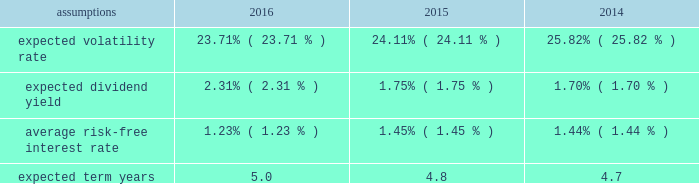Notes to the audited consolidated financial statements director stock compensation subplan eastman's 2016 director stock compensation subplan ( "directors' subplan" ) , a component of the 2012 omnibus plan , remains in effect until terminated by the board of directors or the earlier termination of thf e 2012 omnibus plan .
The directors' subplan provides for structured awards of restricted shares to non-employee members of the board of directors .
Restricted shares awarded under the directors' subplan are subject to the same terms and conditions of the 2012 omnibus plan .
The directors' subplan does not constitute a separate source of shares for grant of equity awards and all shares awarded are part of the 10 million shares authorized under the 2012 omnibus plan .
Shares of restricted stock are granted on the first day of a non-f employee director's initial term of service and shares of restricted stock are granted each year to each non-employee director on the date of the annual meeting of stockholders .
General the company is authorized by the board of directors under the 2012 omnibus plan tof provide awards to employees and non- employee members of the board of directors .
It has been the company's practice to issue new shares rather than treasury shares for equity awards that require settlement by the issuance of common stock and to withhold or accept back shares awarded to cover the related income tax obligations of employee participants .
Shares of unrestricted common stock owned by non-d employee directors are not eligible to be withheld or acquired to satisfy the withholding obligation related to their income taxes .
Aa shares of unrestricted common stock owned by specified senior management level employees are accepted by the company to pay the exercise price of stock options in accordance with the terms and conditions of their awards .
For 2016 , 2015 , and 2014 , total share-based compensation expense ( before tax ) of approximately $ 36 million , $ 36 million , and $ 28 million , respectively , was recognized in selling , general and administrative exd pense in the consolidated statements of earnings , comprehensive income and retained earnings for all share-based awards of which approximately $ 7 million , $ 7 million , and $ 4 million , respectively , related to stock options .
The compensation expense is recognized over the substantive vesting period , which may be a shorter time period than the stated vesting period for qualifying termination eligible employees as defined in the forms of award notice .
For 2016 , 2015 , and 2014 , approximately $ 2 million , $ 2 million , and $ 1 million , respectively , of stock option compensation expense was recognized due to qualifying termination eligibility preceding the requisite vesting period .
Stock option awards options have been granted on an annual basis to non-employee directors under the directors' subplan and predecessor plans and by the compensation and management development committee of the board of directors under the 2012 omnibus plan and predecessor plans to employees .
Option awards have an exercise price equal to the closing price of the company's stock on the date of grant .
The term of options is 10 years with vesting periods thf at vary up to three years .
Vesting usually occurs ratably over the vesting period or at the end of the vesting period .
The company utilizes the black scholes merton option valuation model which relies on certain assumptions to estimate an option's fair value .
The weighted average assumptions used in the determination of fair value for stock options awarded in 2016 , 2015 , and 2014 are provided in the table below: .

What is the percent change in total share-based compensation expense between 2014 and 2015? 
Computations: ((36 - 28) / 28)
Answer: 0.28571. 